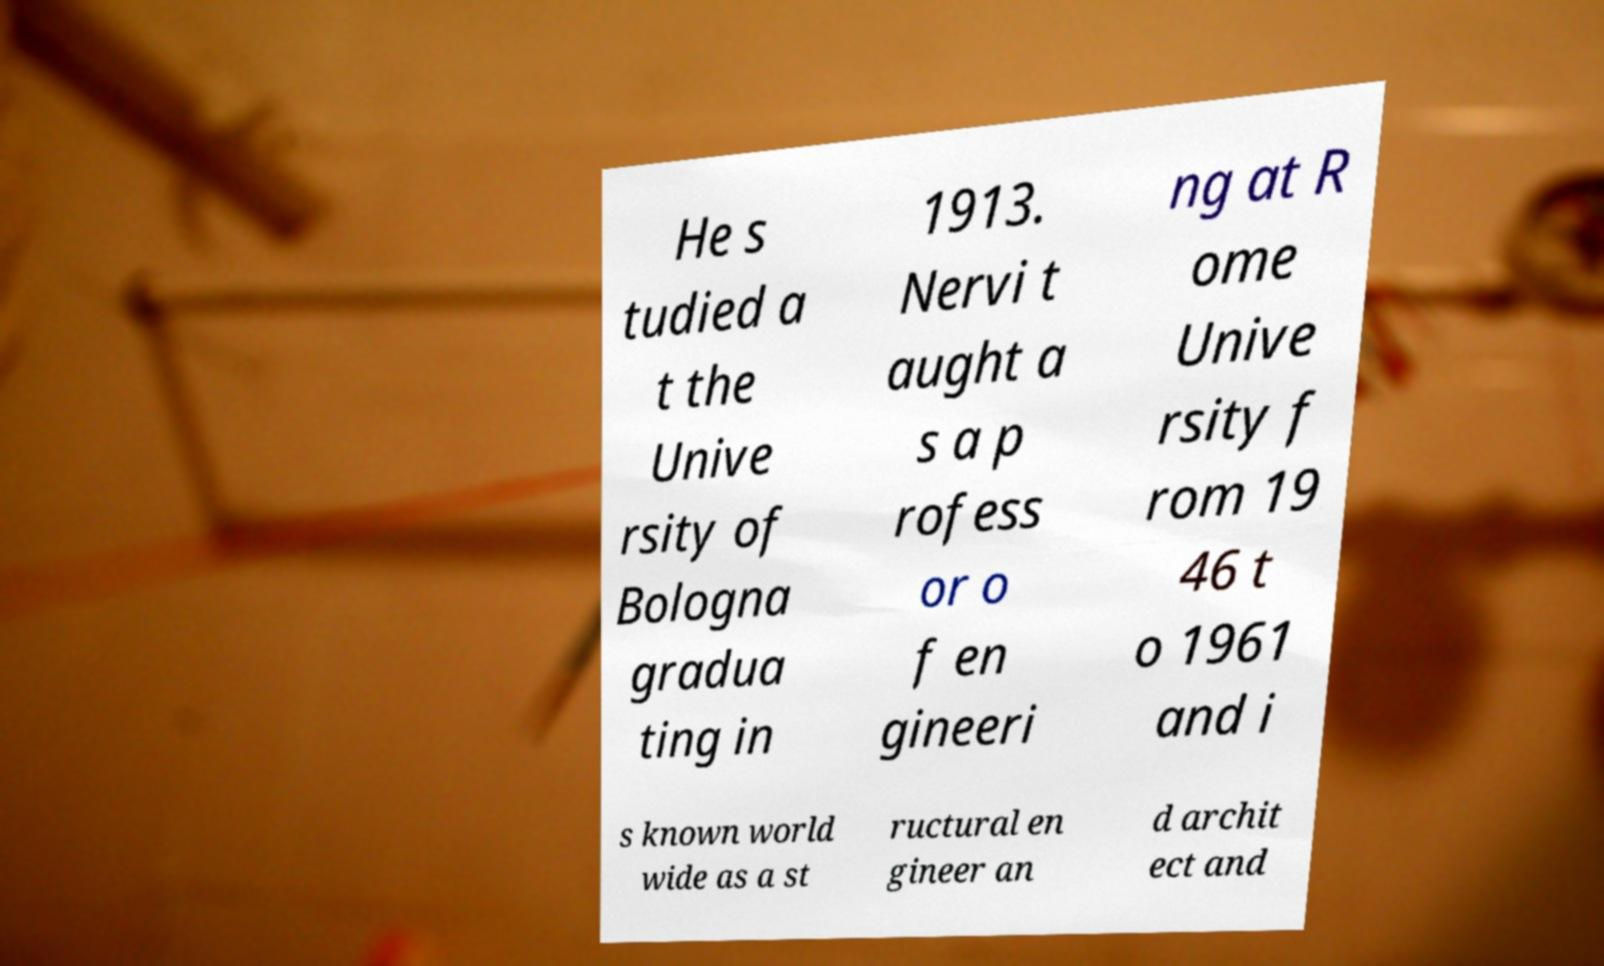For documentation purposes, I need the text within this image transcribed. Could you provide that? He s tudied a t the Unive rsity of Bologna gradua ting in 1913. Nervi t aught a s a p rofess or o f en gineeri ng at R ome Unive rsity f rom 19 46 t o 1961 and i s known world wide as a st ructural en gineer an d archit ect and 